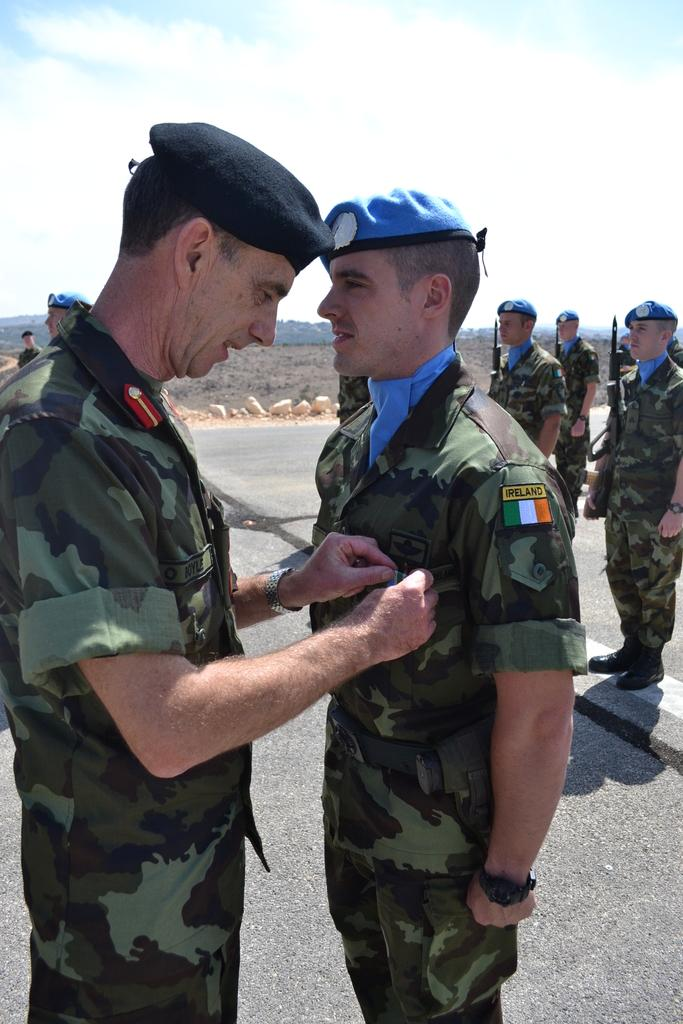What type of people are present in the image? There are army personnel in the image. Where are the army personnel located? The army personnel are standing on the ground. What is the senior army official doing in the image? The senior army official is pinning a badge on the chest of another army official. What is the color of the sky in the image? The sky is blue in the image. What type of disease is being treated by the army personnel in the image? There is no indication of any disease or medical treatment in the image; it features army personnel performing a ceremony. 